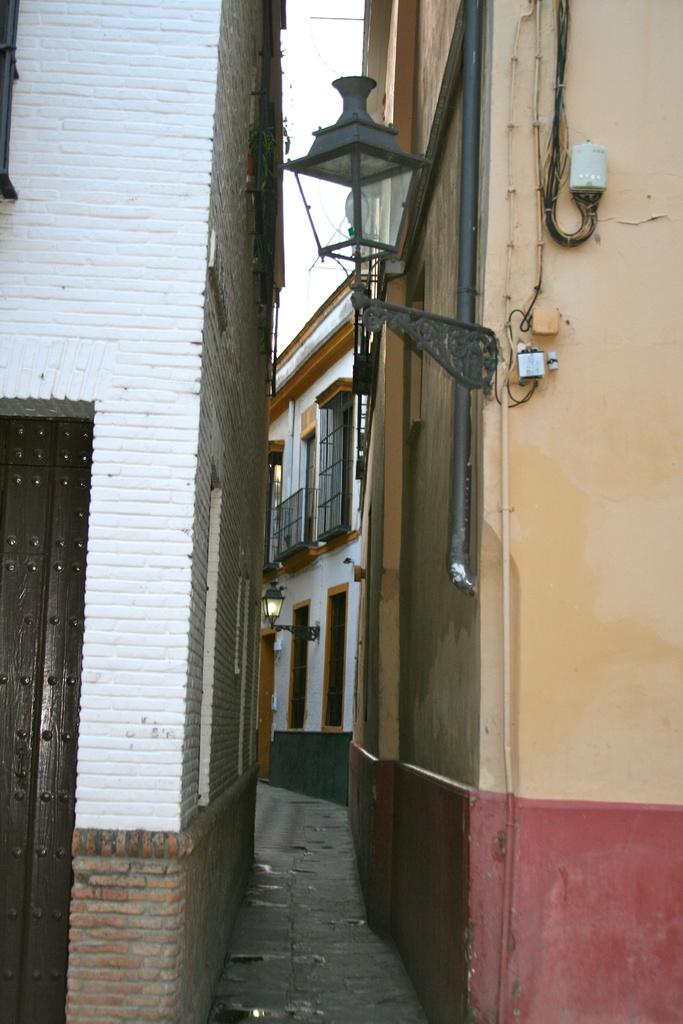What type of structures can be seen in the image? There are buildings in the image. What can be seen illuminating the area in the image? There is a light in the image. What part of the natural environment is visible in the image? The sky is visible in the background of the image. What type of haircut does the building on the left have in the image? Buildings do not have haircuts, as they are inanimate structures. 